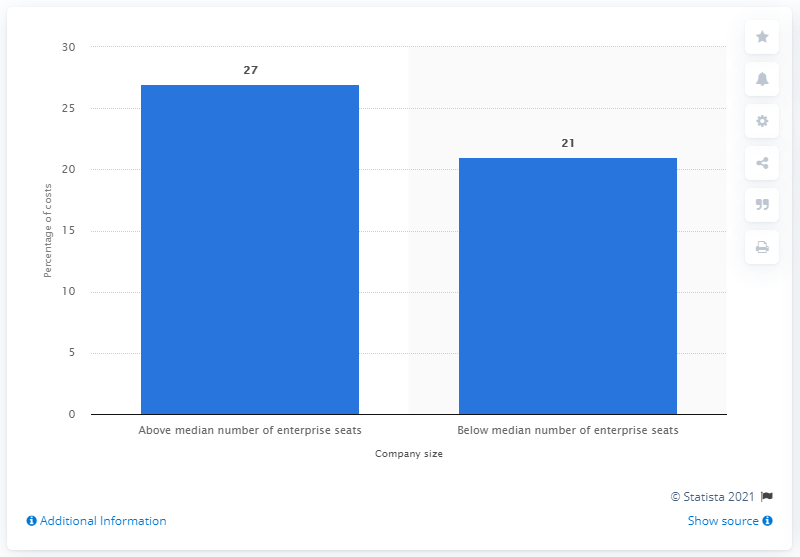Point out several critical features in this image. The percentage of cyber crime costs incurred by companies with fewer than 13,251 enterprise seats was 21%. 